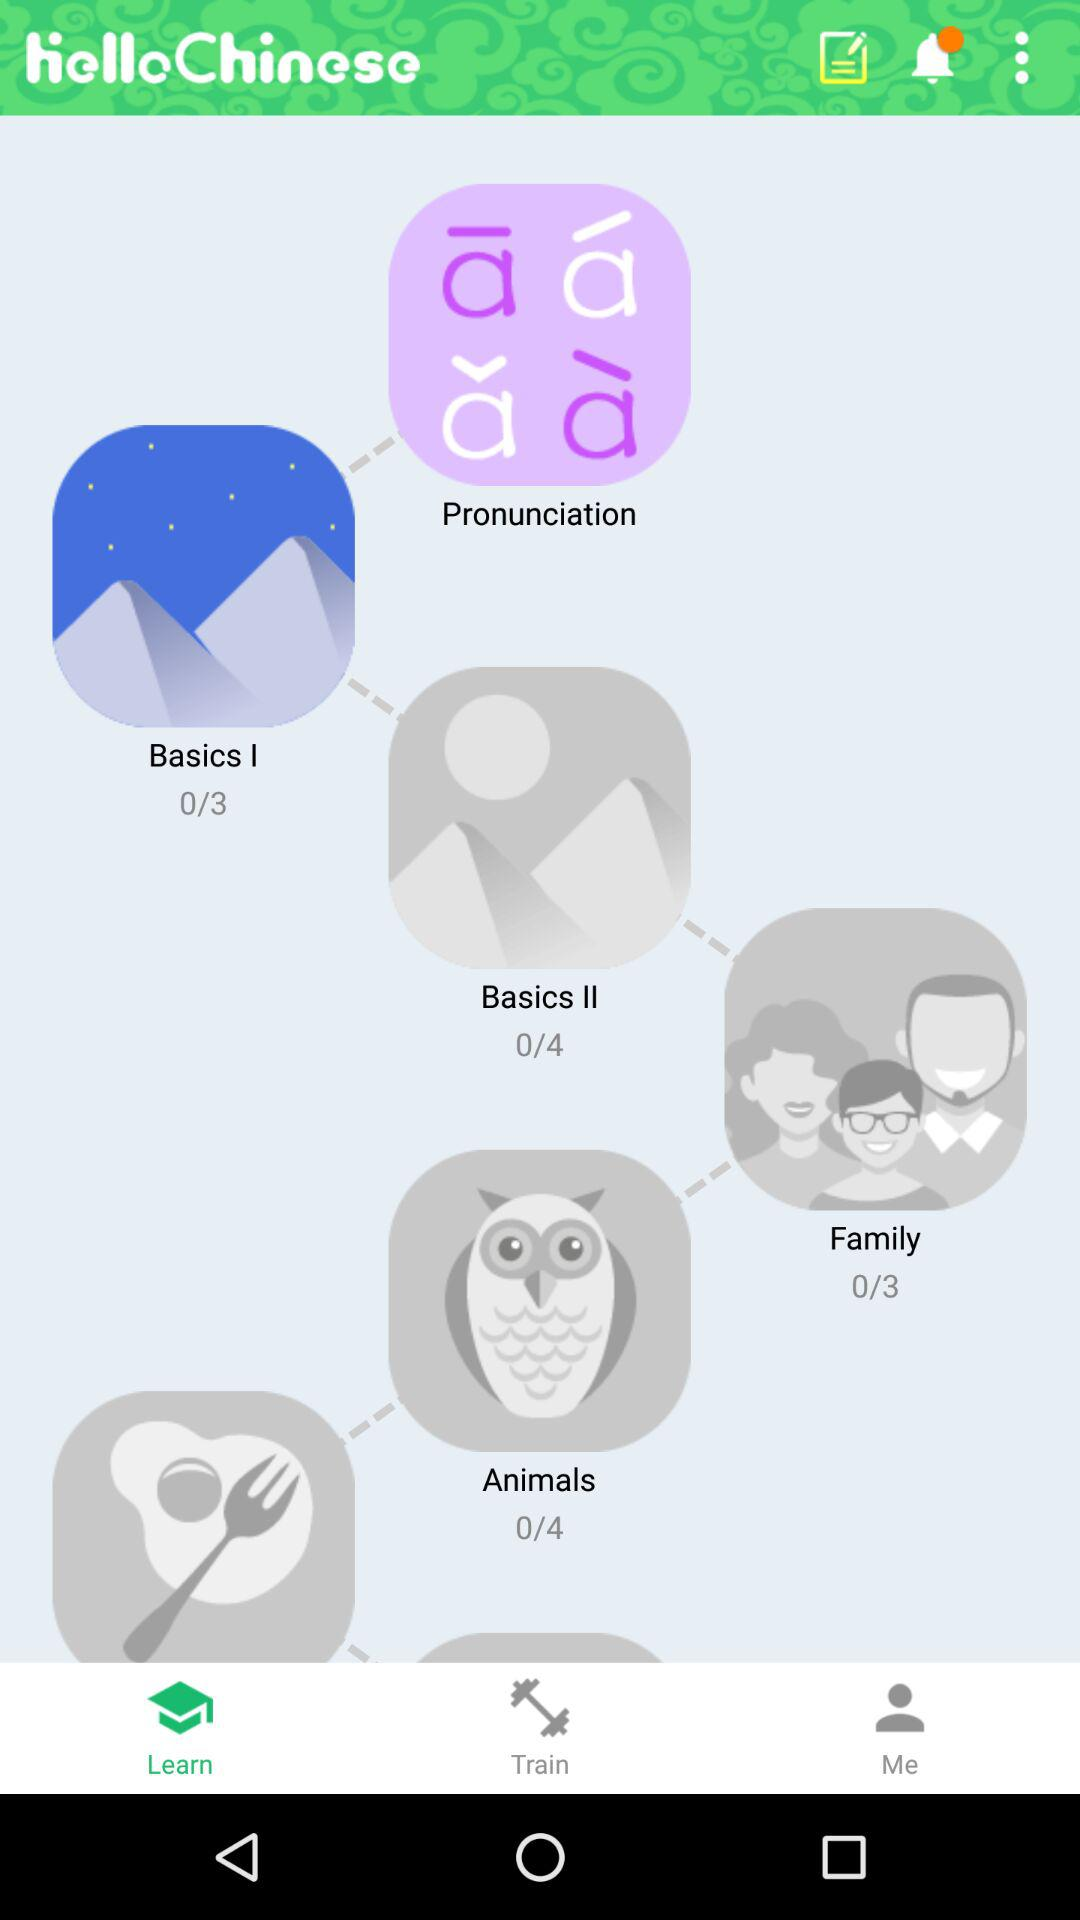What is the application name? The application name is "helloChinese". 